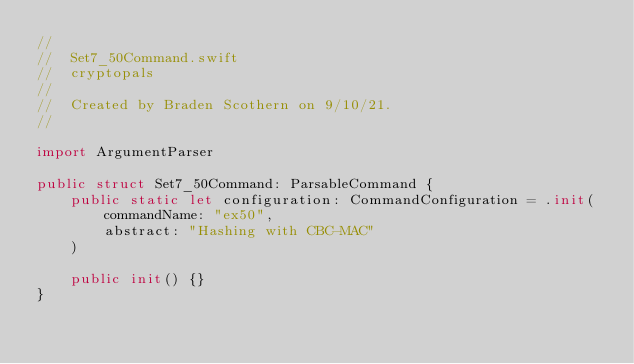Convert code to text. <code><loc_0><loc_0><loc_500><loc_500><_Swift_>//
//  Set7_50Command.swift
//  cryptopals
//
//  Created by Braden Scothern on 9/10/21.
//

import ArgumentParser

public struct Set7_50Command: ParsableCommand {
    public static let configuration: CommandConfiguration = .init(
        commandName: "ex50",
        abstract: "Hashing with CBC-MAC"
    )

    public init() {}
}
</code> 